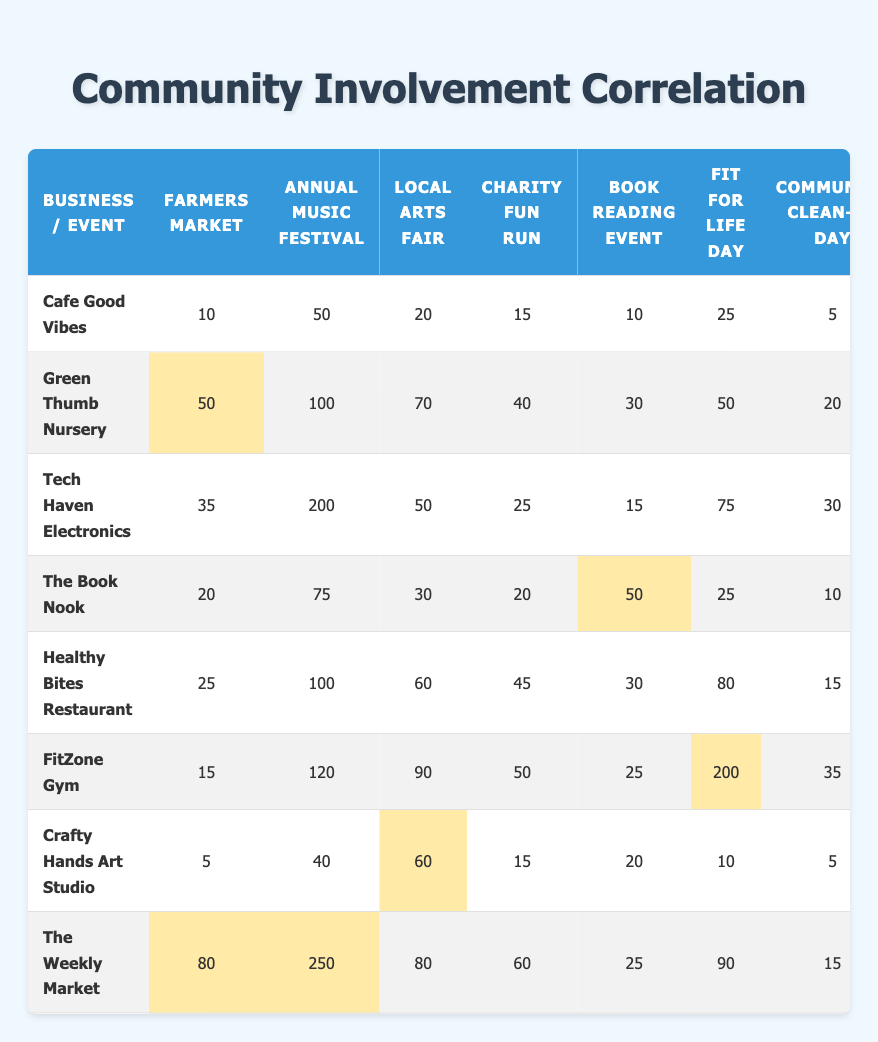What is the total community event participation for the Annual Music Festival? To find the total participation for the Annual Music Festival, I will sum the values across all businesses in that column: 50 (Cafe Good Vibes) + 100 (Green Thumb Nursery) + 200 (Tech Haven Electronics) + 75 (The Book Nook) + 100 (Healthy Bites Restaurant) + 120 (FitZone Gym) + 40 (Crafty Hands Art Studio) + 250 (The Weekly Market) = 935
Answer: 935 Which business sponsored the Local Arts Fair with the highest participation? Looking at the Local Arts Fair column, the values are: 20 (Cafe Good Vibes), 70 (Green Thumb Nursery), 50 (Tech Haven Electronics), 30 (The Book Nook), 60 (Healthy Bites Restaurant), 90 (FitZone Gym), 60 (Crafty Hands Art Studio), and 80 (The Weekly Market). The highest value is 90, which corresponds to FitZone Gym.
Answer: FitZone Gym Did The Book Nook sponsor more participants in the Book Reading Event than FitZone Gym? The values for the Book Reading Event are 50 (The Book Nook) and 25 (FitZone Gym). Since 50 is greater than 25, The Book Nook did in fact sponsor more participants.
Answer: Yes What is the average participation for the Farmers Market across all businesses? To calculate the average, I will first sum the values in the Farmers Market column: 10 (Cafe Good Vibes) + 50 (Green Thumb Nursery) + 35 (Tech Haven Electronics) + 20 (The Book Nook) + 25 (Healthy Bites Restaurant) + 15 (FitZone Gym) + 5 (Crafty Hands Art Studio) + 80 (The Weekly Market) = 240. There are 8 businesses, so the average is 240 / 8 = 30.
Answer: 30 Is the total community event participation for the Fit for Life Day greater than that of the Charity Fun Run? The values for Fit for Life Day are 25 (Cafe Good Vibes) + 50 (Green Thumb Nursery) + 75 (Tech Haven Electronics) + 25 (The Book Nook) + 80 (Healthy Bites Restaurant) + 200 (FitZone Gym) + 10 (Crafty Hands Art Studio) + 90 (The Weekly Market) = 555. For the Charity Fun Run, I sum the values: 15 + 40 + 25 + 20 + 45 + 50 + 15 + 60 = 270. Since 555 is greater than 270, the answer is yes.
Answer: Yes What business had the lowest sponsorship for the Farmers Market? Looking at the Farmers Market column values, the business with the lowest participation is 5 (Crafty Hands Art Studio). Therefore, that is the correct answer.
Answer: Crafty Hands Art Studio 